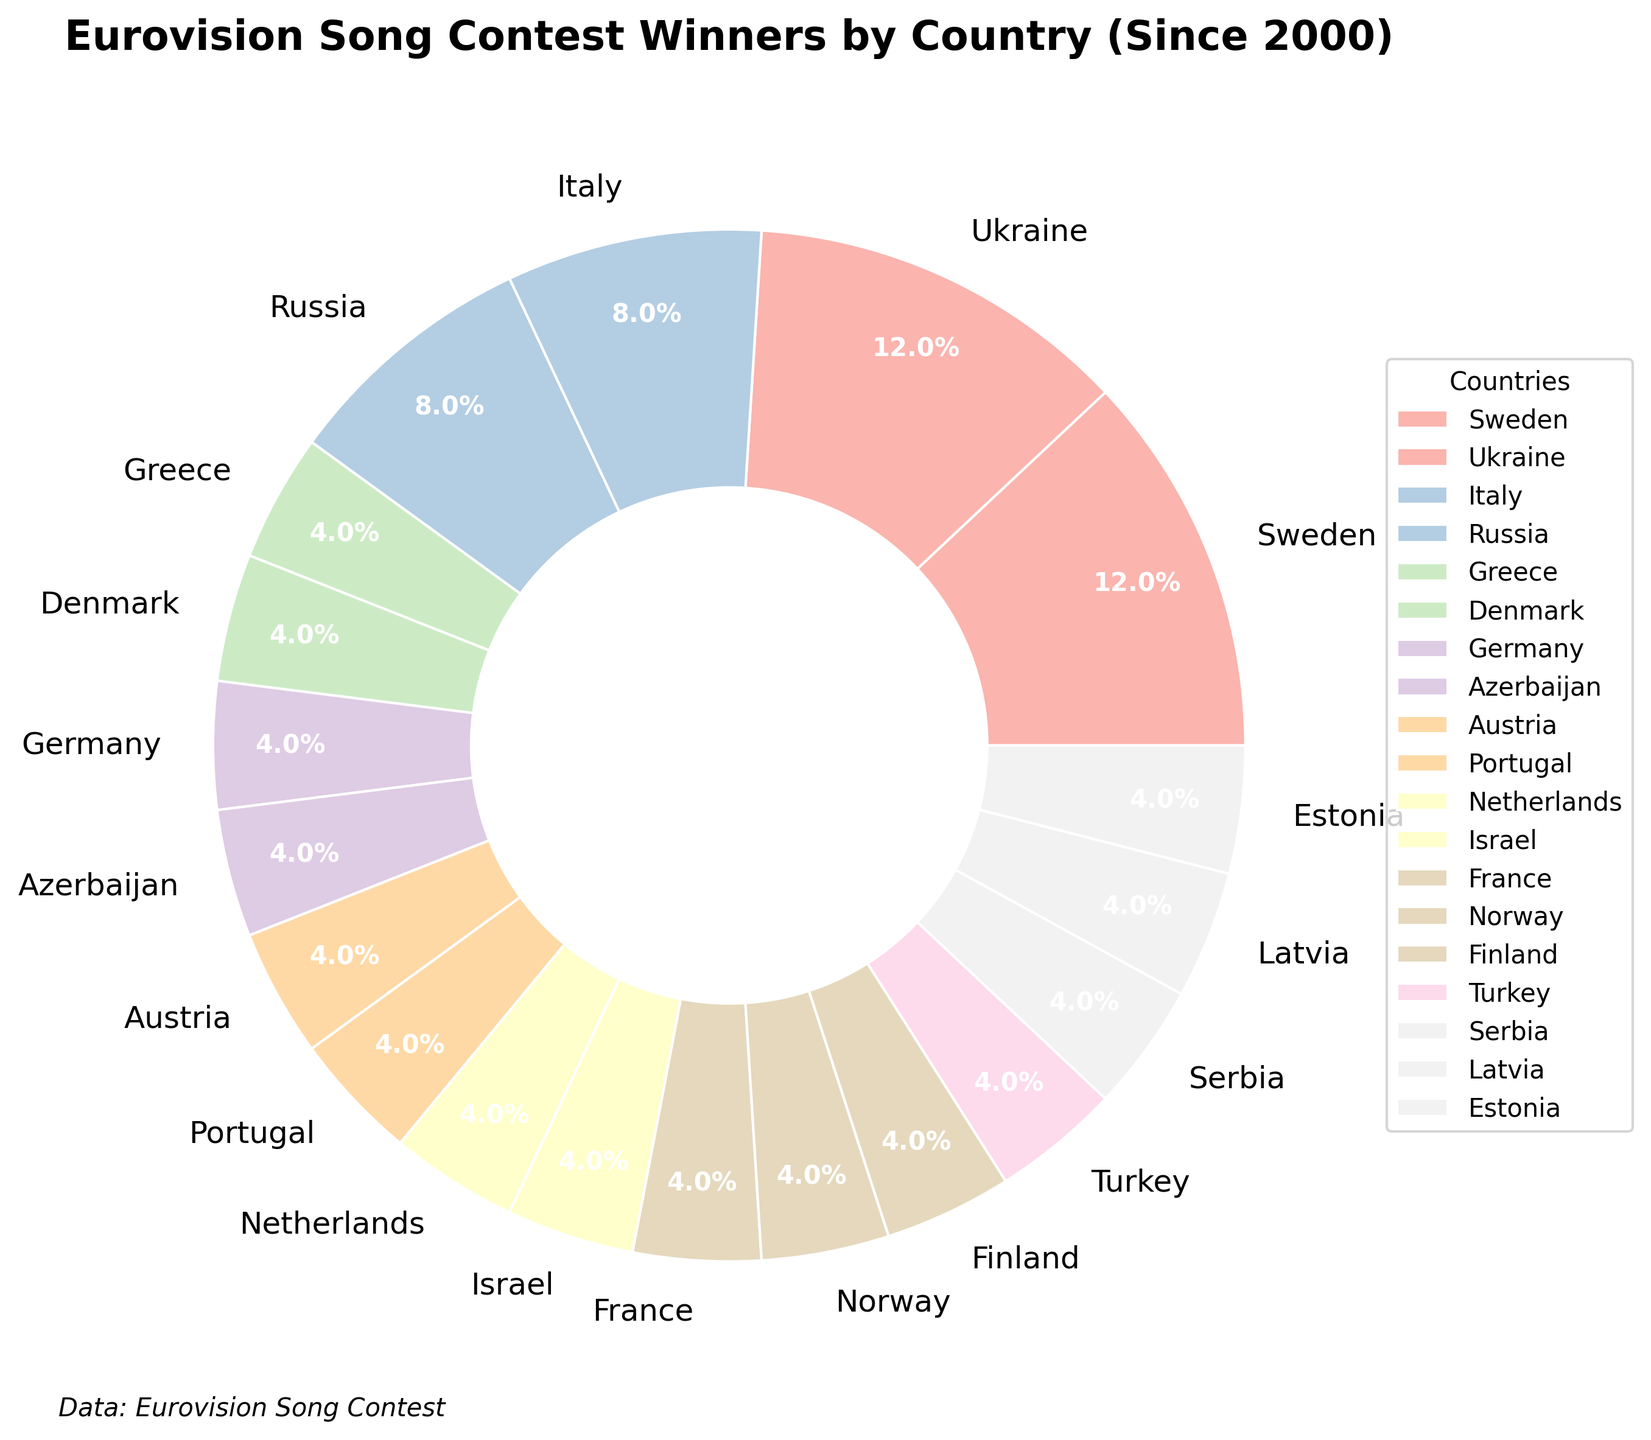Which countries have won the Eurovision Song Contest three times since 2000? By looking at the pie chart, the segments for Sweden and Ukraine show 3 wins each.
Answer: Sweden and Ukraine Which country has the smallest segment in the pie chart? What percentage does it represent? The smallest segments each represent one win. Examining those, we see that each of them represents approximately 5.3%.
Answer: Multiple countries (5.3%) How many countries have exactly one win since 2000? By counting the segments labeled with one win, we find there are fifteen such segments on the pie chart.
Answer: Fifteen countries What is the total number of wins by countries that have won more than once since 2000? Adding up the wins for Sweden (3), Ukraine (3), Italy (2), and Russia (2), the total becomes 3 + 3 + 2 + 2 = 10.
Answer: 10 wins Which country has more wins, Italy or Russia? Comparing the segments for each country, both Italy and Russia have 2 wins each, so they are equal.
Answer: Equal (2 wins each) What color is used to represent Ukraine in the pie chart? Observing the pie chart, we see that Ukraine's segment is tinted with a distinctive color from the custom color palette used in the chart. Explaining specific colors without the chart isn't possible, but it's part of the specified range.
Answer: Part of the custom palette How many countries have won the contest since 2000? Counting the distinct segments, each representing a country, we count a total of 19 countries.
Answer: 19 countries What percentage of the total wins do countries with a single win each contribute? Since 15 countries each have 1 win out of the total 29 wins (3 + 3 + 2 + 2 + 1*15), the percentage is (15/29)*100 ≈ 51.7%.
Answer: 51.7% Which countries combined have more wins than Sweden alone? Adding the wins from any countries with a total exceeding 3 wins. For example, combining Italy (2) and Russia (2) to get 4 wins (which is greater than Sweden's 3 wins).
Answer: Italy and Russia What title and subtitle are displayed above the pie chart? The title "Eurovision Song Contest Winners by Country (Since 2000)" is prominently displayed at the top center.
Answer: Eurovision Song Contest Winners by Country (Since 2000) Who are the five countries with the least number of wins each and what percent do they represent? Analyzing the pie chart, the five countries with the least number of wins (all have 1 win) each represent 5.3% of the total wins. For example, Greece, Denmark, Germany, etc.
Answer: Greece, Denmark, Germany, Azerbaijan, Austria (5.3%) 